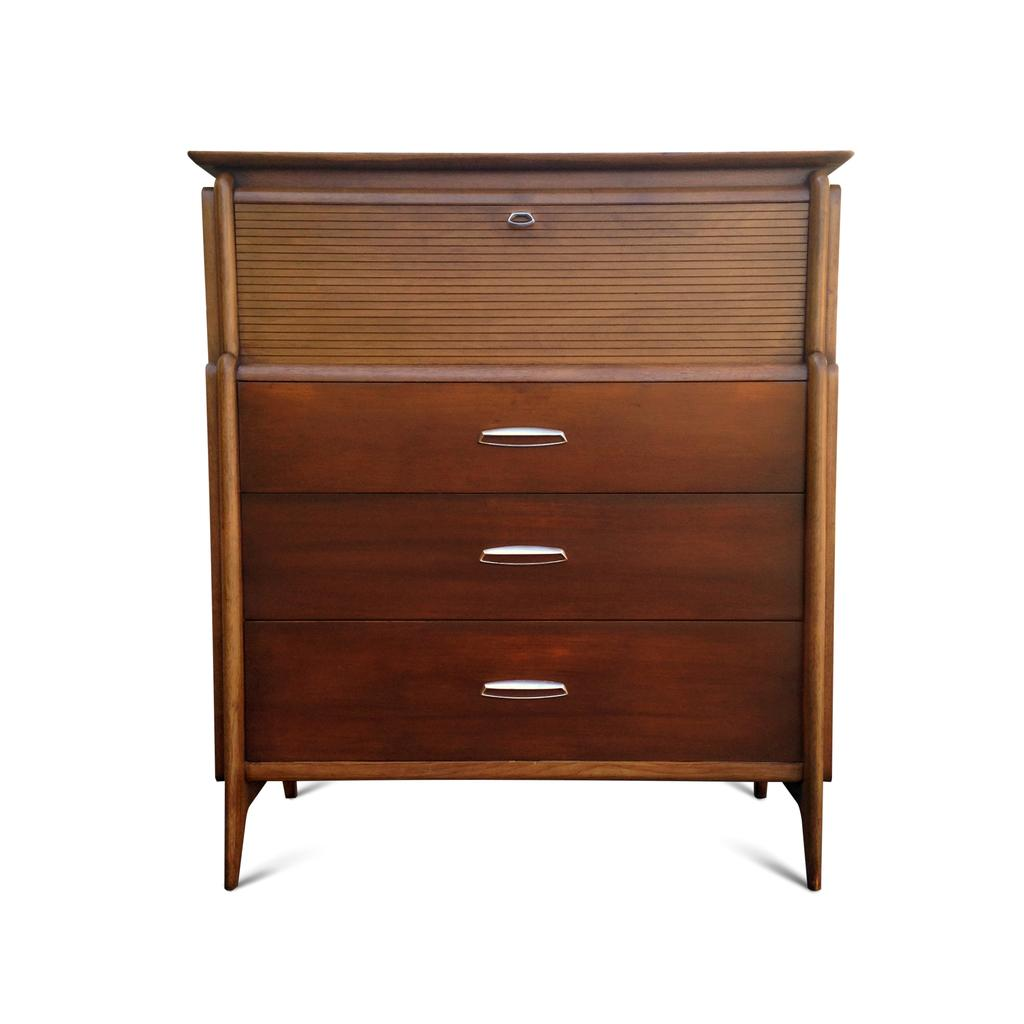What type of furniture is present in the image? There is a cupboard in the image. What feature of the cupboard allows for storage? The cupboard has racks for storage. How can the cupboard be opened or closed? The cupboard has handles for opening and closing. What story is the kitten telling while sitting on the cupboard? There is no kitten present in the image, so no story can be told by a kitten. 